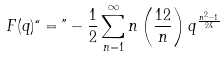Convert formula to latex. <formula><loc_0><loc_0><loc_500><loc_500>F ( q ) ` ` = " - \frac { 1 } { 2 } \sum _ { n = 1 } ^ { \infty } n \left ( \frac { 1 2 } { n } \right ) q ^ { \frac { n ^ { 2 } - 1 } { 2 4 } }</formula> 